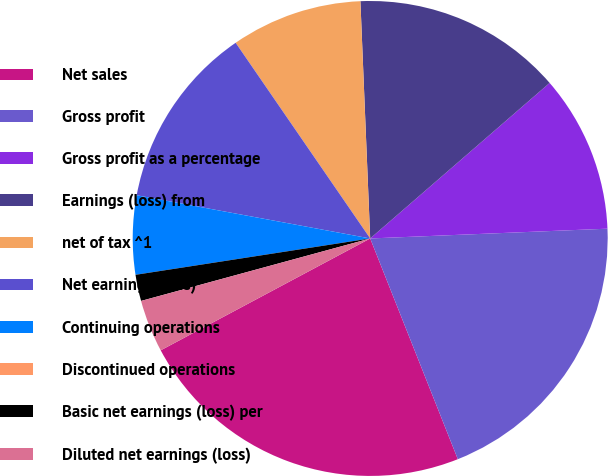<chart> <loc_0><loc_0><loc_500><loc_500><pie_chart><fcel>Net sales<fcel>Gross profit<fcel>Gross profit as a percentage<fcel>Earnings (loss) from<fcel>net of tax ^1<fcel>Net earnings (loss)<fcel>Continuing operations<fcel>Discontinued operations<fcel>Basic net earnings (loss) per<fcel>Diluted net earnings (loss)<nl><fcel>23.21%<fcel>19.64%<fcel>10.71%<fcel>14.29%<fcel>8.93%<fcel>12.5%<fcel>5.36%<fcel>0.0%<fcel>1.79%<fcel>3.57%<nl></chart> 